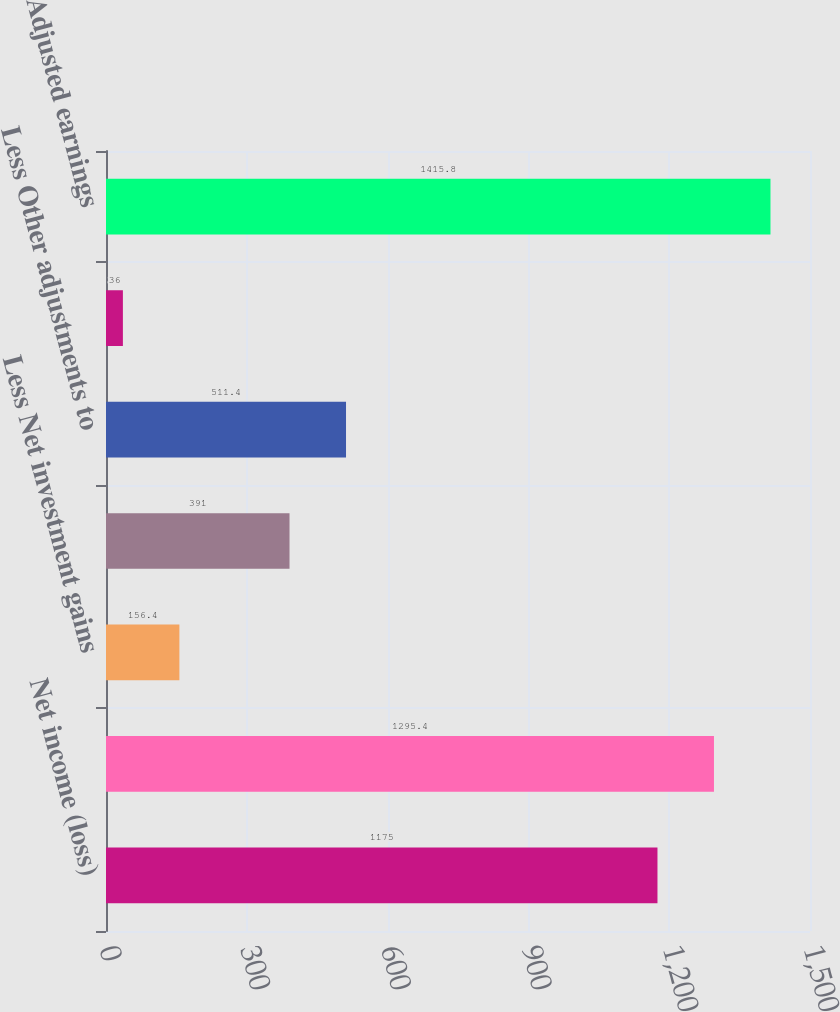Convert chart. <chart><loc_0><loc_0><loc_500><loc_500><bar_chart><fcel>Net income (loss)<fcel>Income (loss) from continuing<fcel>Less Net investment gains<fcel>Less Net derivative gains<fcel>Less Other adjustments to<fcel>Less Provision for income tax<fcel>Adjusted earnings<nl><fcel>1175<fcel>1295.4<fcel>156.4<fcel>391<fcel>511.4<fcel>36<fcel>1415.8<nl></chart> 